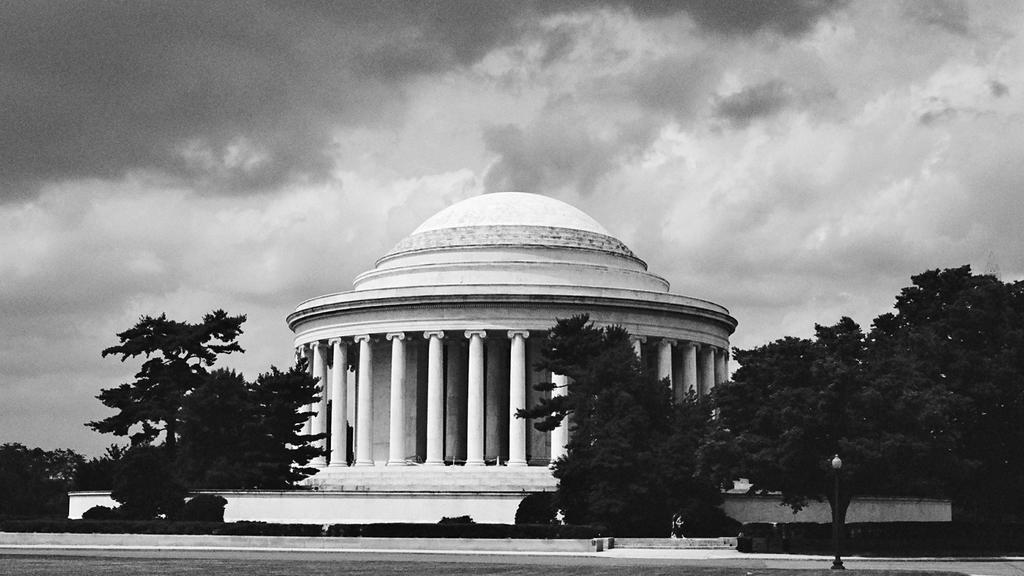Describe this image in one or two sentences. In this picture we can see the road, trees, pillars, building and in the background we can see the sky with clouds. 